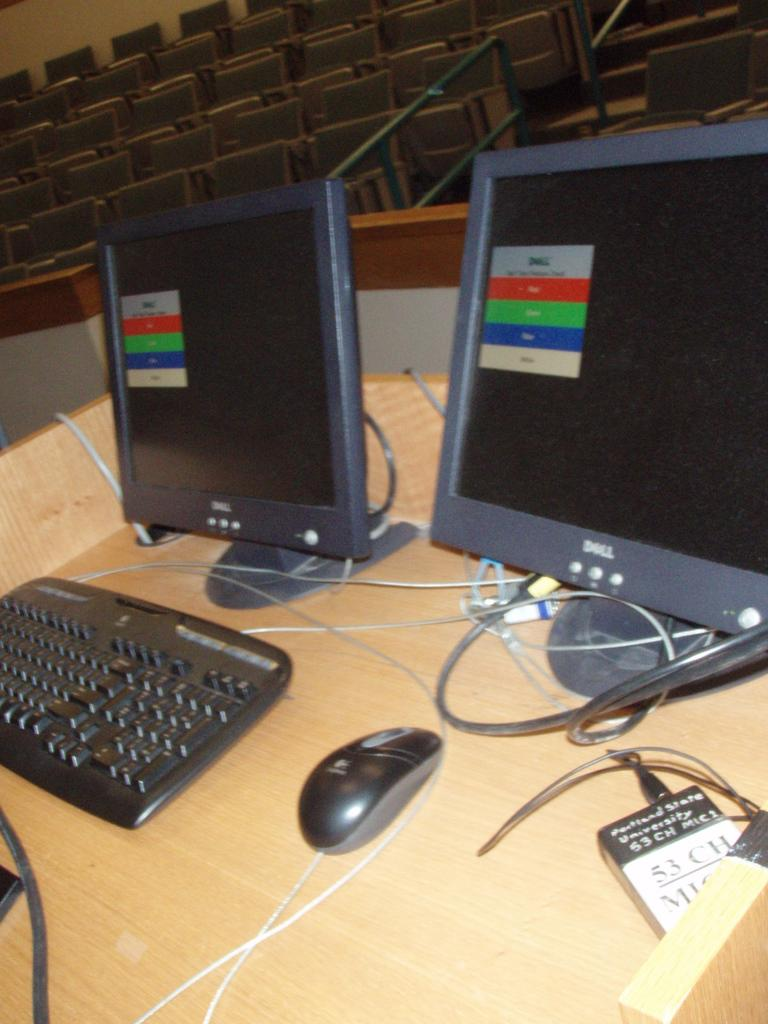<image>
Describe the image concisely. The Dell monitors have five rectangles with different colors. 